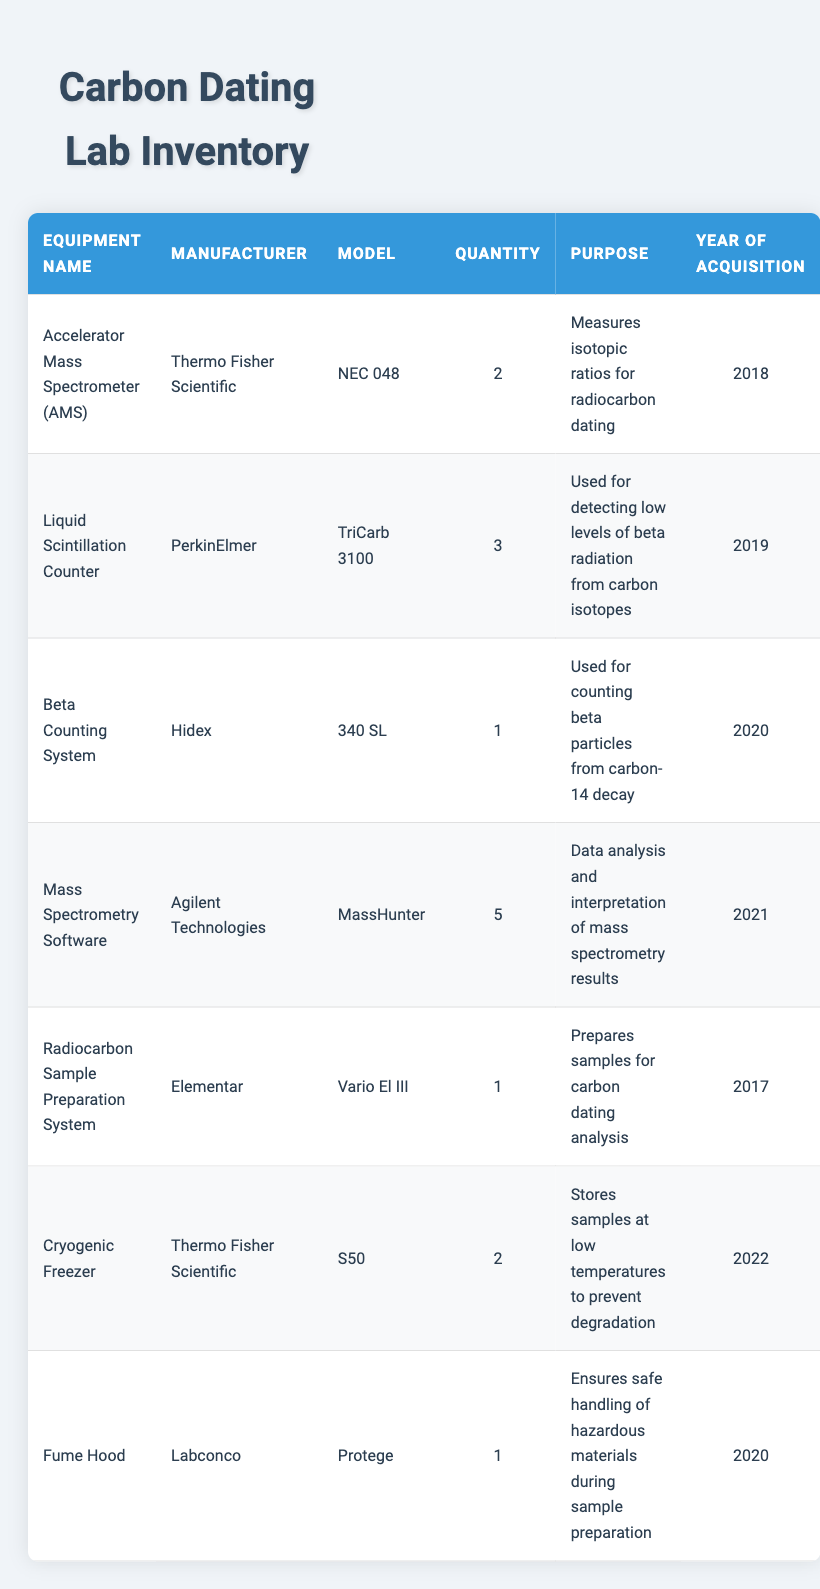What is the model of the Liquid Scintillation Counter? The Liquid Scintillation Counter is manufactured by PerkinElmer and its model is TriCarb 3100, as indicated in the table.
Answer: TriCarb 3100 How many pieces of equipment for sample preparation are listed? There are two pieces of equipment specifically for sample preparation mentioned in the table: the Radiocarbon Sample Preparation System and the Mass Spectrometry Software, which aid in the preparation and analysis of samples respectively.
Answer: 2 Which equipment was acquired in 2019? According to the table, the Liquid Scintillation Counter, manufactured by PerkinElmer, with the model TriCarb 3100 was acquired in 2019.
Answer: Liquid Scintillation Counter Is there any equipment from Thermo Fisher Scientific? Yes, the table lists two pieces of equipment from Thermo Fisher Scientific: the Accelerator Mass Spectrometer (AMS) and the Cryogenic Freezer.
Answer: Yes What is the total quantity of mass spectrometry-related equipment? The Mass Spectrometry Software counts as mass spectrometry-related equipment. There are 5 of these, while the Accelerator Mass Spectrometer (AMS) counts as one more, bringing the total to 6 units.
Answer: 6 What is the average year of acquisition for all the listed equipment? The years of acquisition in the table are 2018, 2019, 2020, 2021, 2017, and 2022. The total is (2018 + 2019 + 2020 + 2021 + 2017 + 2022) = 1217, and there are 6 pieces of equipment. The average is 1217 / 6 = approximately 2020.
Answer: 2020 Which equipment has the highest quantity, and how many units are there? The equipment with the highest quantity is the Mass Spectrometry Software, with 5 units. This is determined by comparing the quantity of all listed items in the table.
Answer: Mass Spectrometry Software, 5 units Is the Beta Counting System the only one of its kind in the inventory? Yes, the Beta Counting System, manufactured by Hidex, is listed with a quantity of 1, indicating that it is the only piece of this specific equipment.
Answer: Yes What is the purpose of the Cryogenic Freezer? The Cryogenic Freezer is used to store samples at low temperatures to prevent degradation, as stated in its description in the table.
Answer: Stores samples at low temperatures to prevent degradation 